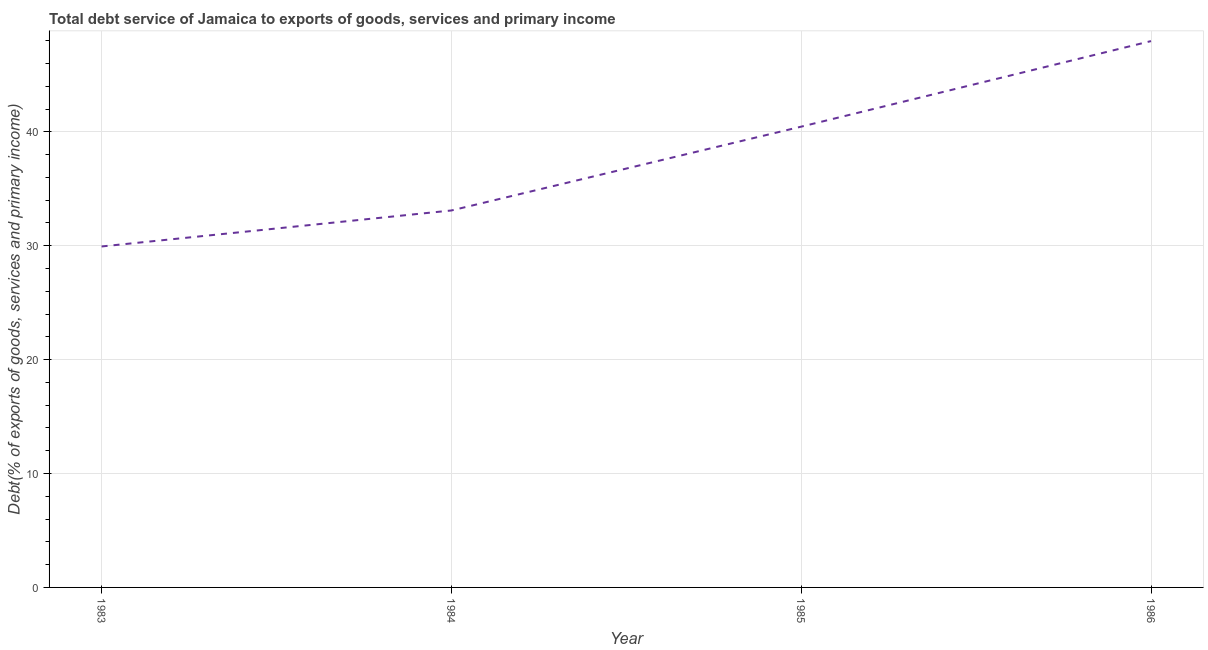What is the total debt service in 1983?
Make the answer very short. 29.94. Across all years, what is the maximum total debt service?
Provide a short and direct response. 47.97. Across all years, what is the minimum total debt service?
Your answer should be compact. 29.94. What is the sum of the total debt service?
Provide a succinct answer. 151.46. What is the difference between the total debt service in 1983 and 1986?
Your answer should be compact. -18.03. What is the average total debt service per year?
Your response must be concise. 37.87. What is the median total debt service?
Provide a short and direct response. 36.78. In how many years, is the total debt service greater than 22 %?
Offer a terse response. 4. Do a majority of the years between 1986 and 1983 (inclusive) have total debt service greater than 46 %?
Provide a succinct answer. Yes. What is the ratio of the total debt service in 1985 to that in 1986?
Make the answer very short. 0.84. Is the total debt service in 1984 less than that in 1985?
Keep it short and to the point. Yes. What is the difference between the highest and the second highest total debt service?
Make the answer very short. 7.51. Is the sum of the total debt service in 1983 and 1986 greater than the maximum total debt service across all years?
Provide a succinct answer. Yes. What is the difference between the highest and the lowest total debt service?
Provide a short and direct response. 18.03. How many lines are there?
Offer a very short reply. 1. What is the title of the graph?
Your answer should be very brief. Total debt service of Jamaica to exports of goods, services and primary income. What is the label or title of the Y-axis?
Ensure brevity in your answer.  Debt(% of exports of goods, services and primary income). What is the Debt(% of exports of goods, services and primary income) in 1983?
Make the answer very short. 29.94. What is the Debt(% of exports of goods, services and primary income) of 1984?
Offer a very short reply. 33.1. What is the Debt(% of exports of goods, services and primary income) of 1985?
Ensure brevity in your answer.  40.46. What is the Debt(% of exports of goods, services and primary income) of 1986?
Your answer should be very brief. 47.97. What is the difference between the Debt(% of exports of goods, services and primary income) in 1983 and 1984?
Offer a very short reply. -3.16. What is the difference between the Debt(% of exports of goods, services and primary income) in 1983 and 1985?
Give a very brief answer. -10.52. What is the difference between the Debt(% of exports of goods, services and primary income) in 1983 and 1986?
Your answer should be very brief. -18.03. What is the difference between the Debt(% of exports of goods, services and primary income) in 1984 and 1985?
Your answer should be very brief. -7.36. What is the difference between the Debt(% of exports of goods, services and primary income) in 1984 and 1986?
Provide a succinct answer. -14.87. What is the difference between the Debt(% of exports of goods, services and primary income) in 1985 and 1986?
Provide a short and direct response. -7.51. What is the ratio of the Debt(% of exports of goods, services and primary income) in 1983 to that in 1984?
Keep it short and to the point. 0.91. What is the ratio of the Debt(% of exports of goods, services and primary income) in 1983 to that in 1985?
Make the answer very short. 0.74. What is the ratio of the Debt(% of exports of goods, services and primary income) in 1983 to that in 1986?
Your answer should be very brief. 0.62. What is the ratio of the Debt(% of exports of goods, services and primary income) in 1984 to that in 1985?
Give a very brief answer. 0.82. What is the ratio of the Debt(% of exports of goods, services and primary income) in 1984 to that in 1986?
Your response must be concise. 0.69. What is the ratio of the Debt(% of exports of goods, services and primary income) in 1985 to that in 1986?
Make the answer very short. 0.84. 